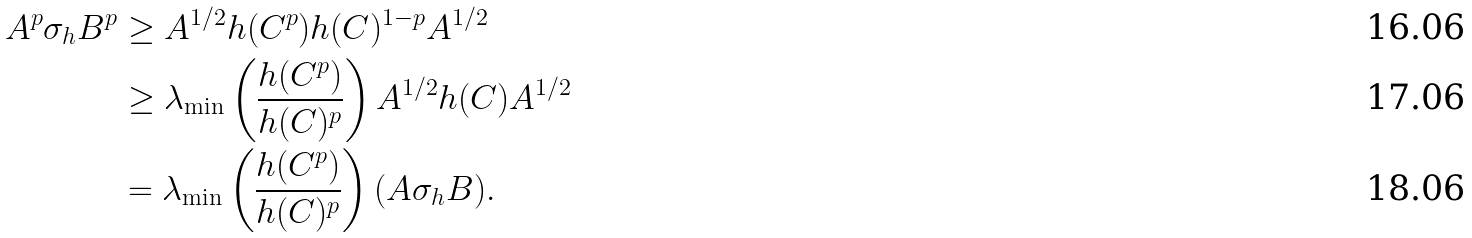<formula> <loc_0><loc_0><loc_500><loc_500>A ^ { p } \sigma _ { h } B ^ { p } & \geq A ^ { 1 / 2 } h ( C ^ { p } ) h ( C ) ^ { 1 - p } A ^ { 1 / 2 } \\ & \geq \lambda _ { \min } \left ( \frac { h ( C ^ { p } ) } { h ( C ) ^ { p } } \right ) A ^ { 1 / 2 } h ( C ) A ^ { 1 / 2 } \\ & = \lambda _ { \min } \left ( \frac { h ( C ^ { p } ) } { h ( C ) ^ { p } } \right ) ( A \sigma _ { h } B ) .</formula> 